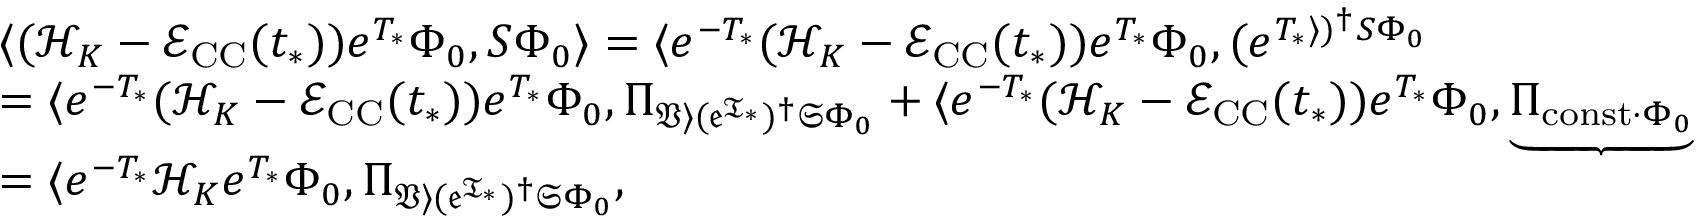<formula> <loc_0><loc_0><loc_500><loc_500>\begin{array} { r l } & { \langle ( \mathcal { H } _ { K } - \mathcal { E } _ { C C } ( t _ { * } ) ) e ^ { T _ { * } } \Phi _ { 0 } , S \Phi _ { 0 } \rangle = \langle e ^ { - T _ { * } } ( \mathcal { H } _ { K } - \mathcal { E } _ { C C } ( t _ { * } ) ) e ^ { T _ { * } } \Phi _ { 0 } , ( e ^ { T _ { * } \rangle ) ^ { \dag } S \Phi _ { 0 } } } \\ & { = \langle e ^ { - T _ { * } } ( \mathcal { H } _ { K } - \mathcal { E } _ { C C } ( t _ { * } ) ) e ^ { T _ { * } } \Phi _ { 0 } , \Pi _ { \mathfrak { V \rangle ( e ^ { T _ { * } } ) ^ { \dag } S \Phi _ { 0 } } } + \langle e ^ { - T _ { * } } ( \mathcal { H } _ { K } - \mathcal { E } _ { C C } ( t _ { * } ) ) e ^ { T _ { * } } \Phi _ { 0 } , \underbrace { \Pi _ { c o n s t \cdot \Phi _ { 0 } } } } \\ & { = \langle e ^ { - T _ { * } } \mathcal { H } _ { K } e ^ { T _ { * } } \Phi _ { 0 } , \Pi _ { \mathfrak { V \rangle ( e ^ { T _ { * } } ) ^ { \dag } S \Phi _ { 0 } } } , } \end{array}</formula> 